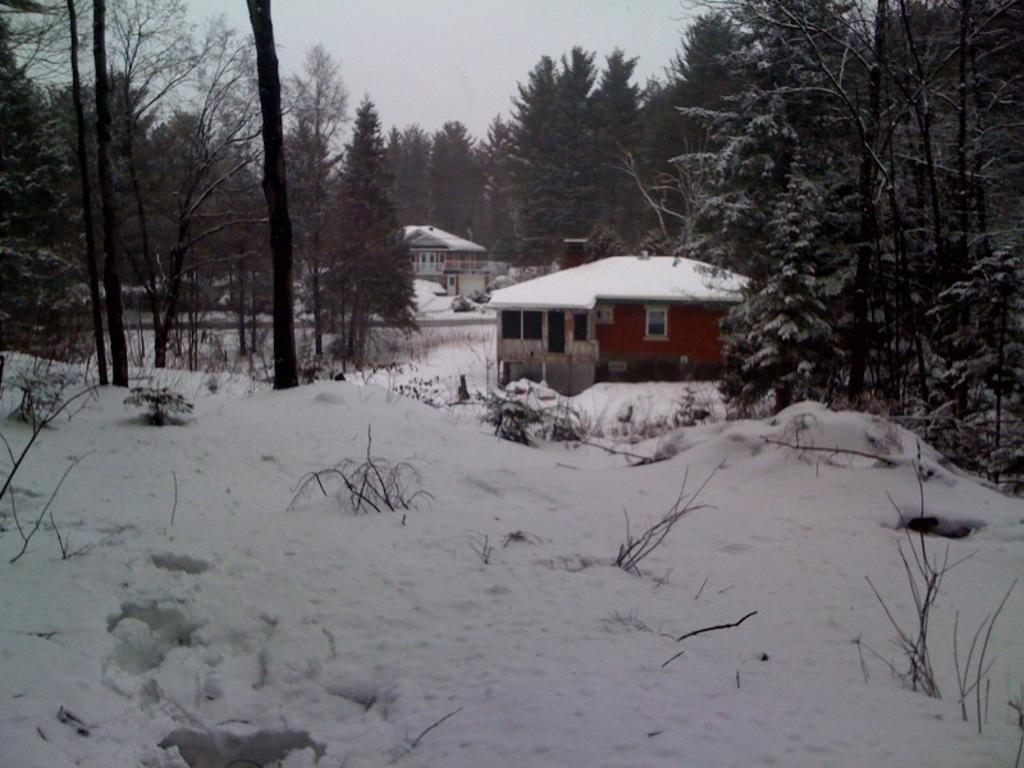What type of vegetation is covered with snow in the image? There are trees covered with snow in the image. What type of structures can be seen in the image? There are houses in the image. What other type of vegetation is present in the image? There are plants in the image. What is the weather condition in the image? Snow is visible in the image. What is visible at the top of the image? The sky is visible at the top of the image. What is the taste of the river in the image? There is no river present in the image, so it is not possible to determine its taste. What type of kettle can be seen in the image? There is no kettle present in the image. 